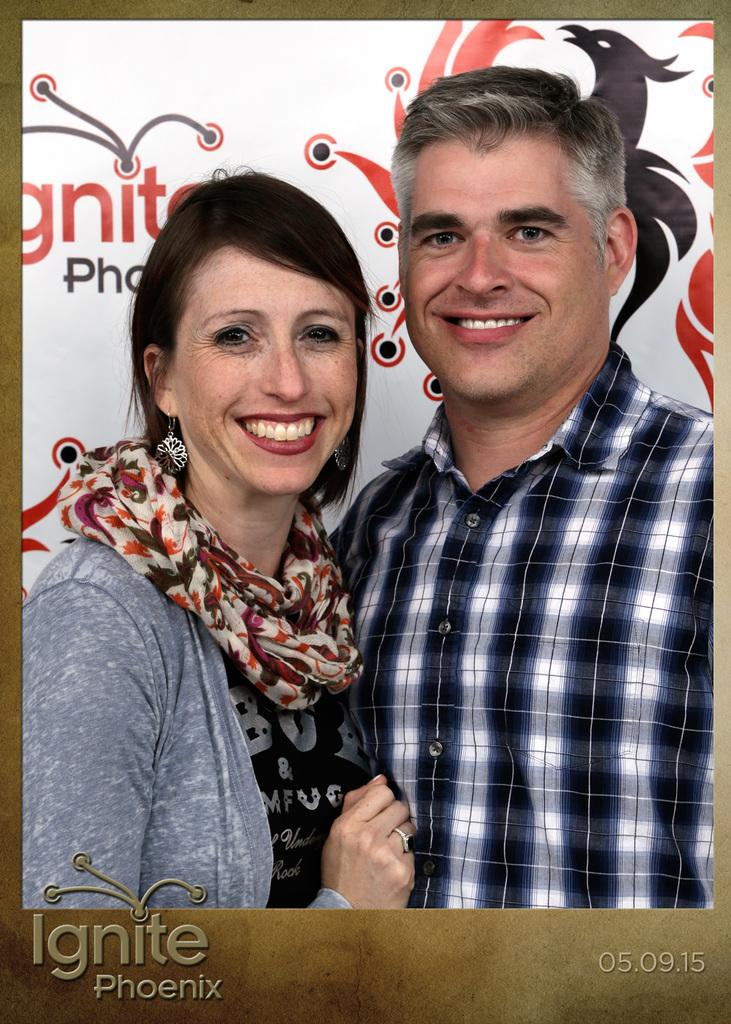What type of image is shown in the picture? The image contains an edited picture. How many people are in the image? There are two persons in the image. What is visible behind the persons? There is text and a logo behind the persons. Where is the text located in the image? There is text at the bottom of the image. Can you see any grapes being eaten by the persons in the image? There is no indication of grapes or any food being eaten in the image. Is there a swimming pool visible in the image? There is no swimming pool or any reference to swimming in the image. 